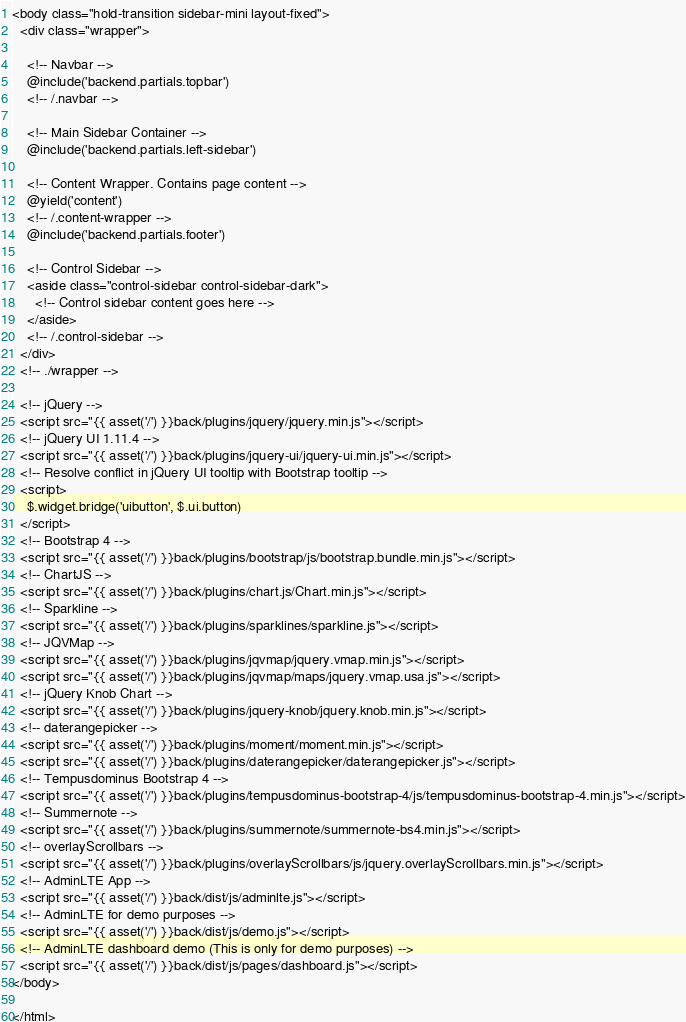Convert code to text. <code><loc_0><loc_0><loc_500><loc_500><_PHP_><body class="hold-transition sidebar-mini layout-fixed">
  <div class="wrapper">

    <!-- Navbar -->
    @include('backend.partials.topbar')
    <!-- /.navbar -->

    <!-- Main Sidebar Container -->
    @include('backend.partials.left-sidebar')

    <!-- Content Wrapper. Contains page content -->
    @yield('content')
    <!-- /.content-wrapper -->
    @include('backend.partials.footer')

    <!-- Control Sidebar -->
    <aside class="control-sidebar control-sidebar-dark">
      <!-- Control sidebar content goes here -->
    </aside>
    <!-- /.control-sidebar -->
  </div>
  <!-- ./wrapper -->

  <!-- jQuery -->
  <script src="{{ asset('/') }}back/plugins/jquery/jquery.min.js"></script>
  <!-- jQuery UI 1.11.4 -->
  <script src="{{ asset('/') }}back/plugins/jquery-ui/jquery-ui.min.js"></script>
  <!-- Resolve conflict in jQuery UI tooltip with Bootstrap tooltip -->
  <script>
    $.widget.bridge('uibutton', $.ui.button)
  </script>
  <!-- Bootstrap 4 -->
  <script src="{{ asset('/') }}back/plugins/bootstrap/js/bootstrap.bundle.min.js"></script>
  <!-- ChartJS -->
  <script src="{{ asset('/') }}back/plugins/chart.js/Chart.min.js"></script>
  <!-- Sparkline -->
  <script src="{{ asset('/') }}back/plugins/sparklines/sparkline.js"></script>
  <!-- JQVMap -->
  <script src="{{ asset('/') }}back/plugins/jqvmap/jquery.vmap.min.js"></script>
  <script src="{{ asset('/') }}back/plugins/jqvmap/maps/jquery.vmap.usa.js"></script>
  <!-- jQuery Knob Chart -->
  <script src="{{ asset('/') }}back/plugins/jquery-knob/jquery.knob.min.js"></script>
  <!-- daterangepicker -->
  <script src="{{ asset('/') }}back/plugins/moment/moment.min.js"></script>
  <script src="{{ asset('/') }}back/plugins/daterangepicker/daterangepicker.js"></script>
  <!-- Tempusdominus Bootstrap 4 -->
  <script src="{{ asset('/') }}back/plugins/tempusdominus-bootstrap-4/js/tempusdominus-bootstrap-4.min.js"></script>
  <!-- Summernote -->
  <script src="{{ asset('/') }}back/plugins/summernote/summernote-bs4.min.js"></script>
  <!-- overlayScrollbars -->
  <script src="{{ asset('/') }}back/plugins/overlayScrollbars/js/jquery.overlayScrollbars.min.js"></script>
  <!-- AdminLTE App -->
  <script src="{{ asset('/') }}back/dist/js/adminlte.js"></script>
  <!-- AdminLTE for demo purposes -->
  <script src="{{ asset('/') }}back/dist/js/demo.js"></script>
  <!-- AdminLTE dashboard demo (This is only for demo purposes) -->
  <script src="{{ asset('/') }}back/dist/js/pages/dashboard.js"></script>
</body>

</html></code> 